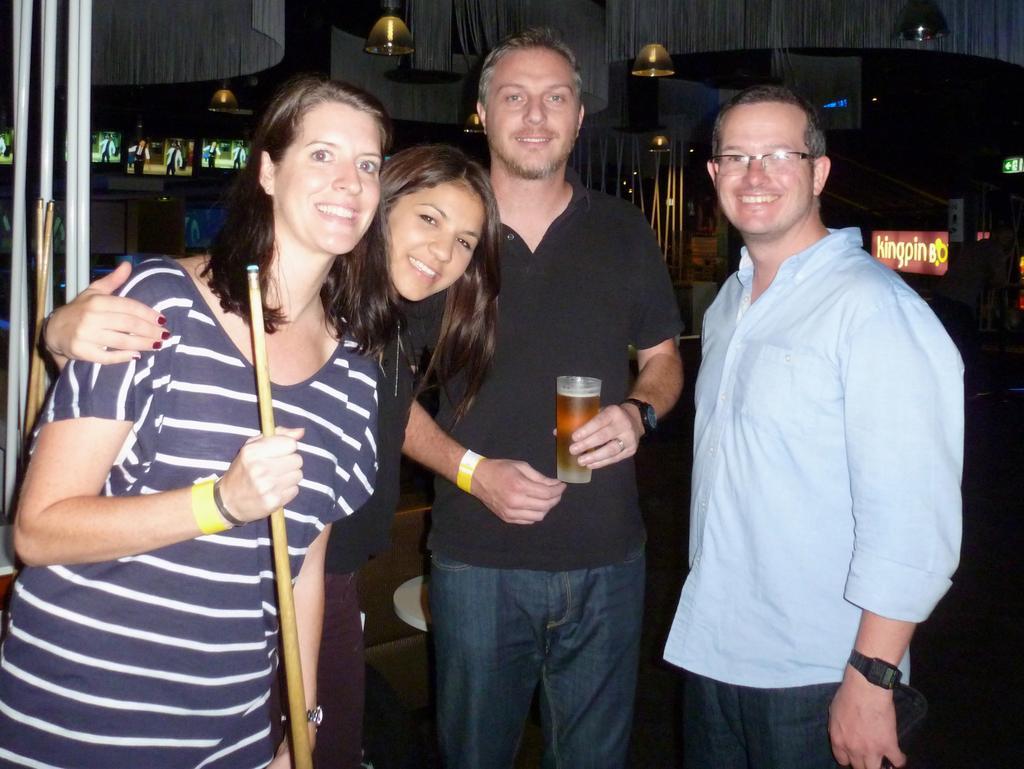Describe this image in one or two sentences. In the center of the image we can see a man is standing and holding a glass which contains beer. On the right side of the image we can see a man is standing and wearing spectacles, dress, watch and holding an object. On the left side of the image we can see two ladies are standing and smiling and a lady is holding a stick. In the background of the image we can see the wall, screen, lights, boards, rods, sign board. At the top we can see the roof. At the bottom of the image we can see the floor. 